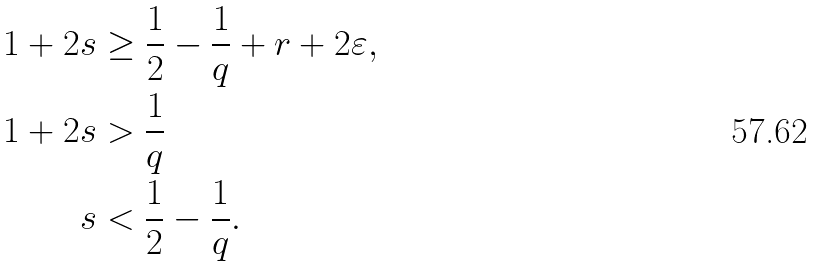Convert formula to latex. <formula><loc_0><loc_0><loc_500><loc_500>1 + 2 s & \geq \frac { 1 } { 2 } - \frac { 1 } { q } + r + 2 \varepsilon , \\ 1 + 2 s & > \frac { 1 } { q } \\ s & < \frac { 1 } { 2 } - \frac { 1 } { q } .</formula> 